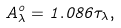Convert formula to latex. <formula><loc_0><loc_0><loc_500><loc_500>A ^ { o } _ { \lambda } = 1 . 0 8 6 \tau _ { \lambda } ,</formula> 